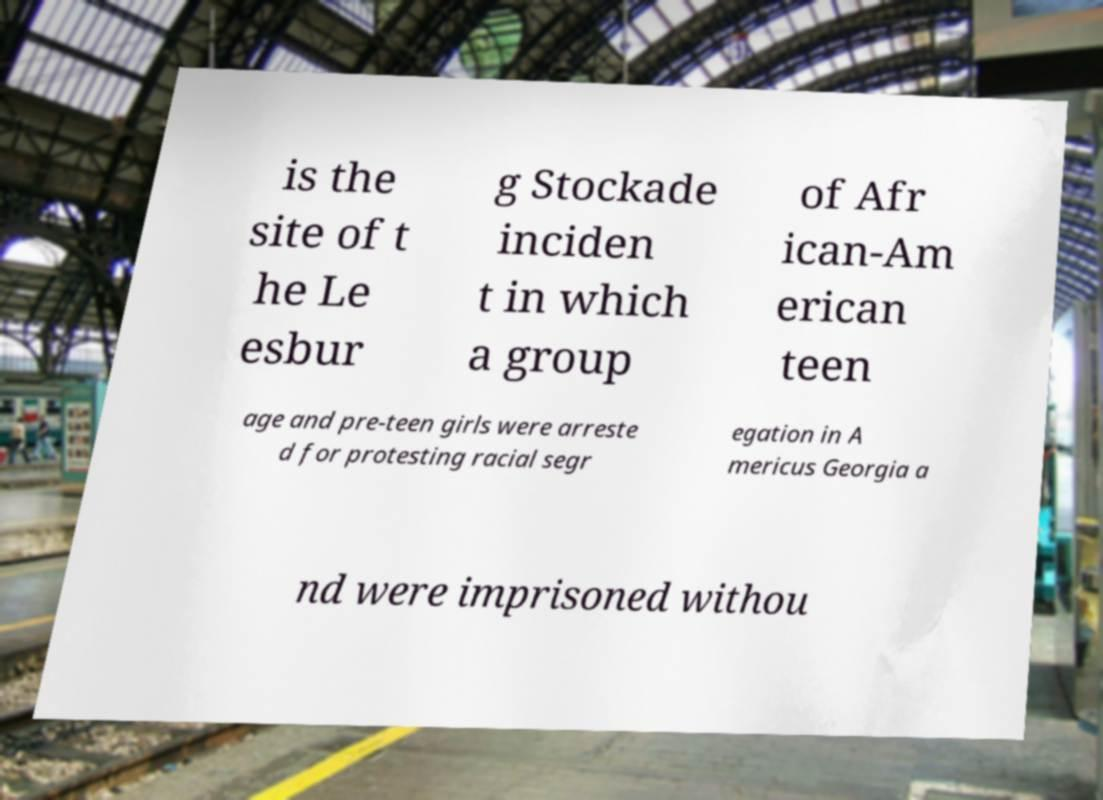Could you extract and type out the text from this image? is the site of t he Le esbur g Stockade inciden t in which a group of Afr ican-Am erican teen age and pre-teen girls were arreste d for protesting racial segr egation in A mericus Georgia a nd were imprisoned withou 